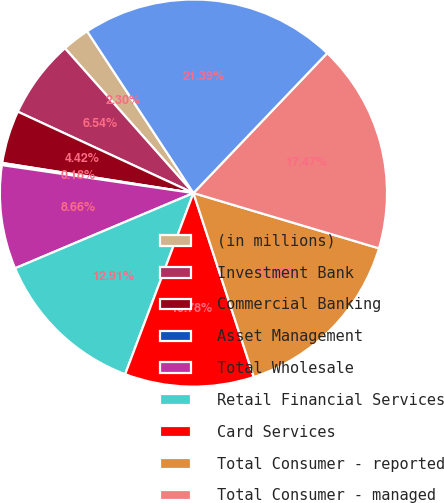Convert chart. <chart><loc_0><loc_0><loc_500><loc_500><pie_chart><fcel>(in millions)<fcel>Investment Bank<fcel>Commercial Banking<fcel>Asset Management<fcel>Total Wholesale<fcel>Retail Financial Services<fcel>Card Services<fcel>Total Consumer - reported<fcel>Total Consumer - managed<fcel>Total<nl><fcel>2.3%<fcel>6.54%<fcel>4.42%<fcel>0.18%<fcel>8.66%<fcel>12.91%<fcel>10.78%<fcel>15.35%<fcel>17.47%<fcel>21.39%<nl></chart> 